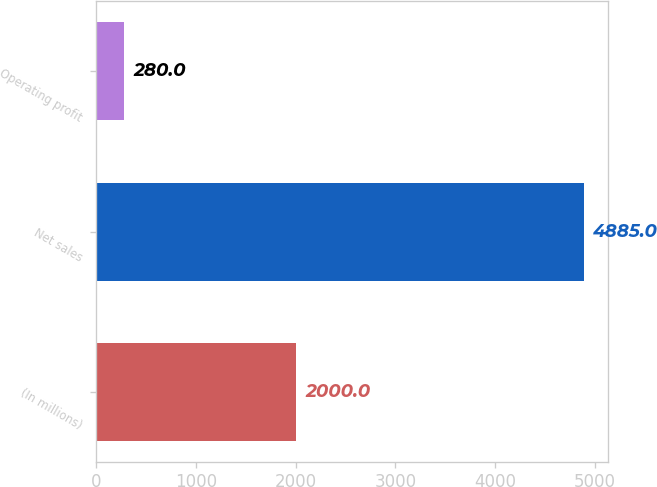Convert chart. <chart><loc_0><loc_0><loc_500><loc_500><bar_chart><fcel>(In millions)<fcel>Net sales<fcel>Operating profit<nl><fcel>2000<fcel>4885<fcel>280<nl></chart> 